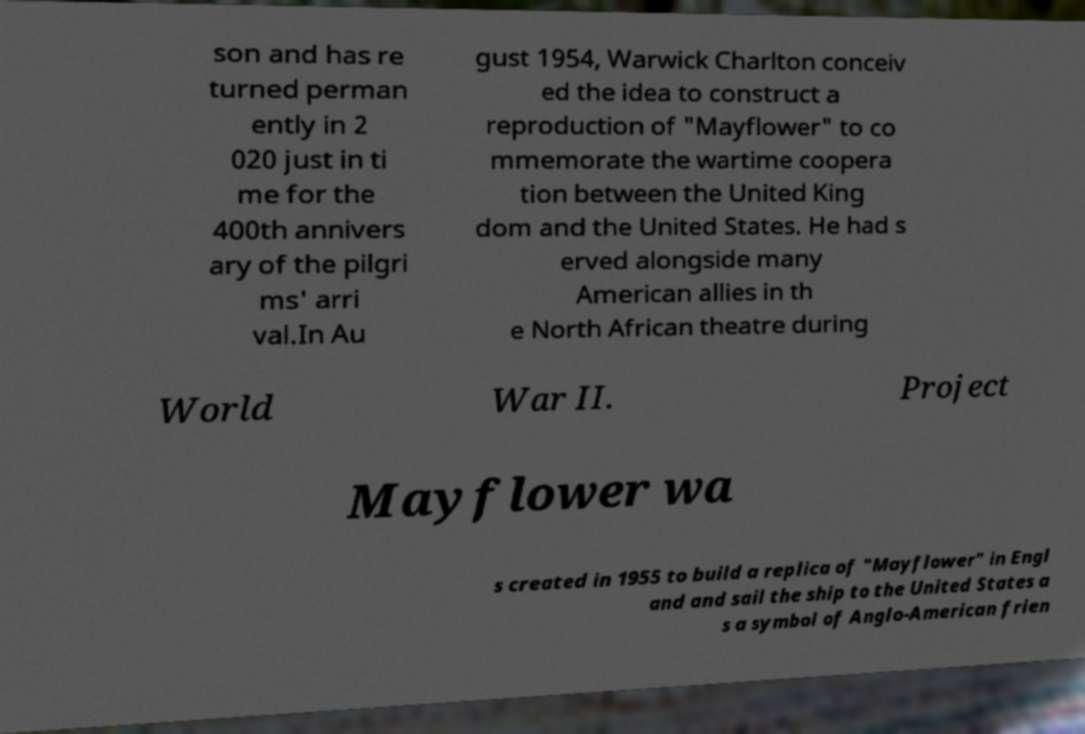Can you read and provide the text displayed in the image?This photo seems to have some interesting text. Can you extract and type it out for me? son and has re turned perman ently in 2 020 just in ti me for the 400th annivers ary of the pilgri ms' arri val.In Au gust 1954, Warwick Charlton conceiv ed the idea to construct a reproduction of "Mayflower" to co mmemorate the wartime coopera tion between the United King dom and the United States. He had s erved alongside many American allies in th e North African theatre during World War II. Project Mayflower wa s created in 1955 to build a replica of "Mayflower" in Engl and and sail the ship to the United States a s a symbol of Anglo-American frien 